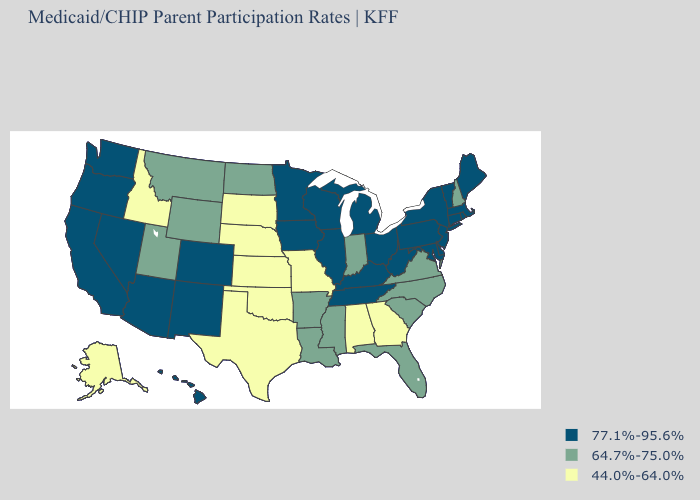What is the value of Missouri?
Concise answer only. 44.0%-64.0%. Name the states that have a value in the range 77.1%-95.6%?
Quick response, please. Arizona, California, Colorado, Connecticut, Delaware, Hawaii, Illinois, Iowa, Kentucky, Maine, Maryland, Massachusetts, Michigan, Minnesota, Nevada, New Jersey, New Mexico, New York, Ohio, Oregon, Pennsylvania, Rhode Island, Tennessee, Vermont, Washington, West Virginia, Wisconsin. Which states have the highest value in the USA?
Be succinct. Arizona, California, Colorado, Connecticut, Delaware, Hawaii, Illinois, Iowa, Kentucky, Maine, Maryland, Massachusetts, Michigan, Minnesota, Nevada, New Jersey, New Mexico, New York, Ohio, Oregon, Pennsylvania, Rhode Island, Tennessee, Vermont, Washington, West Virginia, Wisconsin. Name the states that have a value in the range 77.1%-95.6%?
Keep it brief. Arizona, California, Colorado, Connecticut, Delaware, Hawaii, Illinois, Iowa, Kentucky, Maine, Maryland, Massachusetts, Michigan, Minnesota, Nevada, New Jersey, New Mexico, New York, Ohio, Oregon, Pennsylvania, Rhode Island, Tennessee, Vermont, Washington, West Virginia, Wisconsin. What is the value of Ohio?
Answer briefly. 77.1%-95.6%. What is the value of Nebraska?
Quick response, please. 44.0%-64.0%. Does Alabama have the highest value in the USA?
Be succinct. No. What is the value of Illinois?
Quick response, please. 77.1%-95.6%. Does the map have missing data?
Keep it brief. No. What is the value of South Dakota?
Answer briefly. 44.0%-64.0%. Which states have the highest value in the USA?
Concise answer only. Arizona, California, Colorado, Connecticut, Delaware, Hawaii, Illinois, Iowa, Kentucky, Maine, Maryland, Massachusetts, Michigan, Minnesota, Nevada, New Jersey, New Mexico, New York, Ohio, Oregon, Pennsylvania, Rhode Island, Tennessee, Vermont, Washington, West Virginia, Wisconsin. What is the value of Hawaii?
Quick response, please. 77.1%-95.6%. Name the states that have a value in the range 44.0%-64.0%?
Keep it brief. Alabama, Alaska, Georgia, Idaho, Kansas, Missouri, Nebraska, Oklahoma, South Dakota, Texas. What is the highest value in the USA?
Quick response, please. 77.1%-95.6%. What is the value of California?
Quick response, please. 77.1%-95.6%. 